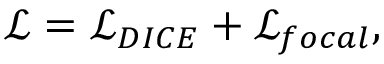Convert formula to latex. <formula><loc_0><loc_0><loc_500><loc_500>\mathcal { L } = \mathcal { L } _ { D I C E } + \mathcal { L } _ { f o c a l } ,</formula> 